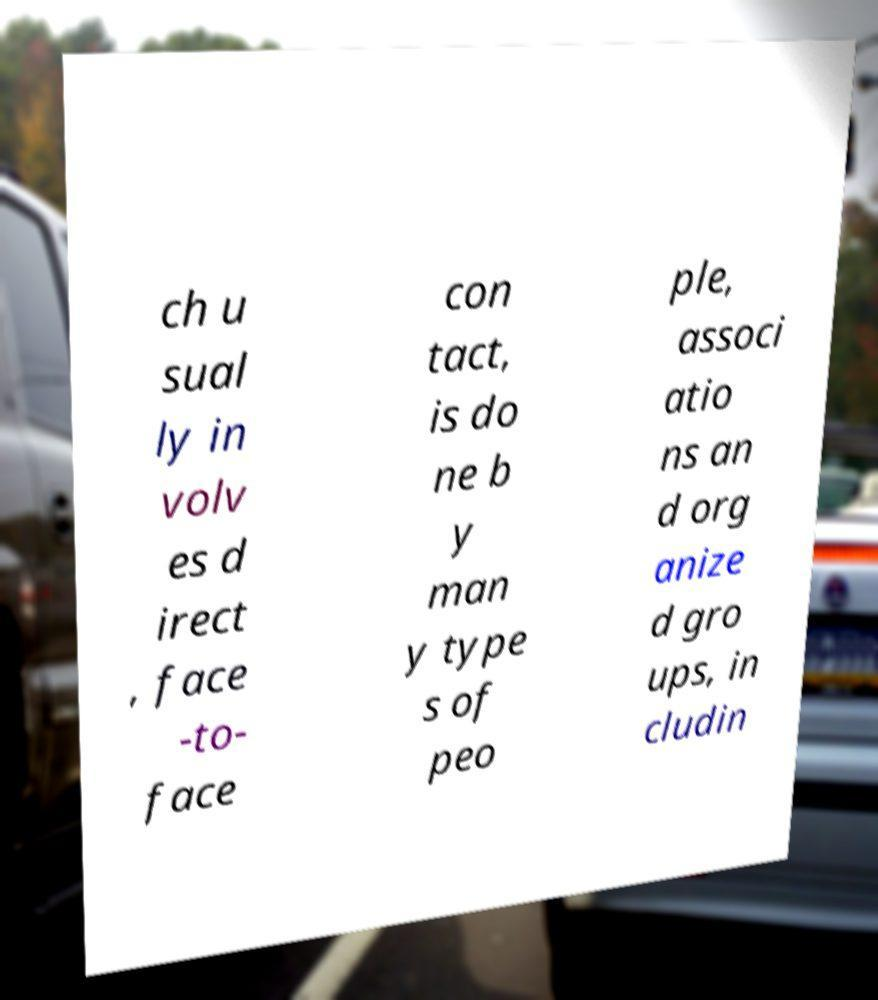For documentation purposes, I need the text within this image transcribed. Could you provide that? ch u sual ly in volv es d irect , face -to- face con tact, is do ne b y man y type s of peo ple, associ atio ns an d org anize d gro ups, in cludin 